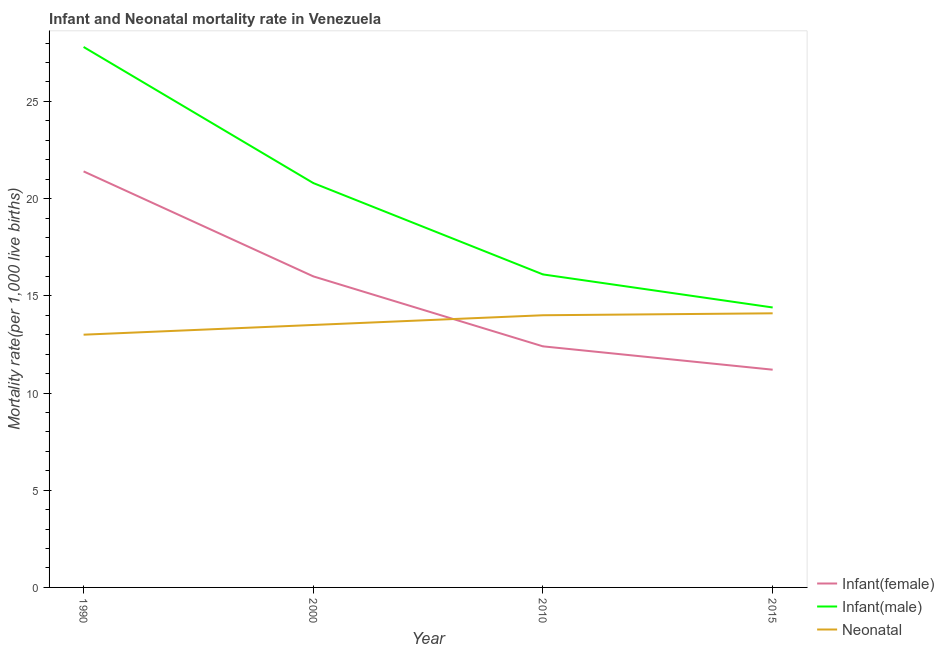How many different coloured lines are there?
Provide a short and direct response. 3. Is the number of lines equal to the number of legend labels?
Your answer should be compact. Yes. Across all years, what is the maximum infant mortality rate(female)?
Give a very brief answer. 21.4. In which year was the infant mortality rate(male) minimum?
Provide a succinct answer. 2015. What is the total infant mortality rate(female) in the graph?
Ensure brevity in your answer.  61. What is the difference between the infant mortality rate(female) in 2015 and the neonatal mortality rate in 1990?
Offer a terse response. -1.8. What is the average infant mortality rate(male) per year?
Ensure brevity in your answer.  19.78. In the year 1990, what is the difference between the infant mortality rate(female) and infant mortality rate(male)?
Offer a terse response. -6.4. In how many years, is the infant mortality rate(male) greater than 6?
Ensure brevity in your answer.  4. What is the ratio of the neonatal mortality rate in 2000 to that in 2010?
Your answer should be compact. 0.96. Is the infant mortality rate(female) in 1990 less than that in 2010?
Your answer should be compact. No. Is the difference between the neonatal mortality rate in 1990 and 2010 greater than the difference between the infant mortality rate(male) in 1990 and 2010?
Keep it short and to the point. No. What is the difference between the highest and the second highest neonatal mortality rate?
Keep it short and to the point. 0.1. What is the difference between the highest and the lowest neonatal mortality rate?
Offer a very short reply. 1.1. In how many years, is the infant mortality rate(male) greater than the average infant mortality rate(male) taken over all years?
Provide a short and direct response. 2. Is it the case that in every year, the sum of the infant mortality rate(female) and infant mortality rate(male) is greater than the neonatal mortality rate?
Offer a terse response. Yes. Is the infant mortality rate(male) strictly less than the neonatal mortality rate over the years?
Your answer should be very brief. No. How many lines are there?
Provide a short and direct response. 3. What is the difference between two consecutive major ticks on the Y-axis?
Make the answer very short. 5. Are the values on the major ticks of Y-axis written in scientific E-notation?
Provide a succinct answer. No. Does the graph contain any zero values?
Offer a very short reply. No. Does the graph contain grids?
Ensure brevity in your answer.  No. Where does the legend appear in the graph?
Keep it short and to the point. Bottom right. How many legend labels are there?
Offer a very short reply. 3. How are the legend labels stacked?
Offer a very short reply. Vertical. What is the title of the graph?
Provide a short and direct response. Infant and Neonatal mortality rate in Venezuela. Does "New Zealand" appear as one of the legend labels in the graph?
Your answer should be compact. No. What is the label or title of the Y-axis?
Provide a short and direct response. Mortality rate(per 1,0 live births). What is the Mortality rate(per 1,000 live births) in Infant(female) in 1990?
Offer a terse response. 21.4. What is the Mortality rate(per 1,000 live births) in Infant(male) in 1990?
Give a very brief answer. 27.8. What is the Mortality rate(per 1,000 live births) in Infant(male) in 2000?
Offer a terse response. 20.8. What is the Mortality rate(per 1,000 live births) of Infant(female) in 2010?
Provide a short and direct response. 12.4. What is the Mortality rate(per 1,000 live births) of Infant(female) in 2015?
Provide a short and direct response. 11.2. What is the Mortality rate(per 1,000 live births) of Infant(male) in 2015?
Your answer should be very brief. 14.4. What is the Mortality rate(per 1,000 live births) in Neonatal  in 2015?
Provide a succinct answer. 14.1. Across all years, what is the maximum Mortality rate(per 1,000 live births) in Infant(female)?
Keep it short and to the point. 21.4. Across all years, what is the maximum Mortality rate(per 1,000 live births) in Infant(male)?
Your answer should be compact. 27.8. Across all years, what is the maximum Mortality rate(per 1,000 live births) of Neonatal ?
Give a very brief answer. 14.1. Across all years, what is the minimum Mortality rate(per 1,000 live births) in Infant(male)?
Your answer should be very brief. 14.4. Across all years, what is the minimum Mortality rate(per 1,000 live births) of Neonatal ?
Your answer should be very brief. 13. What is the total Mortality rate(per 1,000 live births) of Infant(male) in the graph?
Your answer should be very brief. 79.1. What is the total Mortality rate(per 1,000 live births) in Neonatal  in the graph?
Provide a succinct answer. 54.6. What is the difference between the Mortality rate(per 1,000 live births) in Infant(male) in 1990 and that in 2000?
Keep it short and to the point. 7. What is the difference between the Mortality rate(per 1,000 live births) of Infant(female) in 1990 and that in 2010?
Make the answer very short. 9. What is the difference between the Mortality rate(per 1,000 live births) in Infant(male) in 1990 and that in 2010?
Your answer should be compact. 11.7. What is the difference between the Mortality rate(per 1,000 live births) of Infant(male) in 1990 and that in 2015?
Offer a terse response. 13.4. What is the difference between the Mortality rate(per 1,000 live births) of Neonatal  in 1990 and that in 2015?
Make the answer very short. -1.1. What is the difference between the Mortality rate(per 1,000 live births) in Infant(female) in 2000 and that in 2010?
Make the answer very short. 3.6. What is the difference between the Mortality rate(per 1,000 live births) of Infant(female) in 2000 and that in 2015?
Give a very brief answer. 4.8. What is the difference between the Mortality rate(per 1,000 live births) of Infant(female) in 2010 and that in 2015?
Your answer should be very brief. 1.2. What is the difference between the Mortality rate(per 1,000 live births) in Infant(female) in 1990 and the Mortality rate(per 1,000 live births) in Infant(male) in 2000?
Give a very brief answer. 0.6. What is the difference between the Mortality rate(per 1,000 live births) of Infant(female) in 1990 and the Mortality rate(per 1,000 live births) of Infant(male) in 2015?
Make the answer very short. 7. What is the difference between the Mortality rate(per 1,000 live births) in Infant(female) in 2000 and the Mortality rate(per 1,000 live births) in Infant(male) in 2010?
Keep it short and to the point. -0.1. What is the difference between the Mortality rate(per 1,000 live births) of Infant(male) in 2000 and the Mortality rate(per 1,000 live births) of Neonatal  in 2010?
Provide a succinct answer. 6.8. What is the difference between the Mortality rate(per 1,000 live births) of Infant(female) in 2000 and the Mortality rate(per 1,000 live births) of Infant(male) in 2015?
Your answer should be compact. 1.6. What is the difference between the Mortality rate(per 1,000 live births) in Infant(female) in 2000 and the Mortality rate(per 1,000 live births) in Neonatal  in 2015?
Ensure brevity in your answer.  1.9. What is the difference between the Mortality rate(per 1,000 live births) in Infant(male) in 2000 and the Mortality rate(per 1,000 live births) in Neonatal  in 2015?
Ensure brevity in your answer.  6.7. What is the difference between the Mortality rate(per 1,000 live births) in Infant(female) in 2010 and the Mortality rate(per 1,000 live births) in Infant(male) in 2015?
Offer a terse response. -2. What is the difference between the Mortality rate(per 1,000 live births) in Infant(male) in 2010 and the Mortality rate(per 1,000 live births) in Neonatal  in 2015?
Give a very brief answer. 2. What is the average Mortality rate(per 1,000 live births) in Infant(female) per year?
Your response must be concise. 15.25. What is the average Mortality rate(per 1,000 live births) in Infant(male) per year?
Your answer should be very brief. 19.77. What is the average Mortality rate(per 1,000 live births) of Neonatal  per year?
Provide a short and direct response. 13.65. In the year 1990, what is the difference between the Mortality rate(per 1,000 live births) in Infant(female) and Mortality rate(per 1,000 live births) in Neonatal ?
Your answer should be very brief. 8.4. In the year 2000, what is the difference between the Mortality rate(per 1,000 live births) of Infant(male) and Mortality rate(per 1,000 live births) of Neonatal ?
Keep it short and to the point. 7.3. In the year 2010, what is the difference between the Mortality rate(per 1,000 live births) in Infant(female) and Mortality rate(per 1,000 live births) in Infant(male)?
Your answer should be very brief. -3.7. In the year 2010, what is the difference between the Mortality rate(per 1,000 live births) in Infant(female) and Mortality rate(per 1,000 live births) in Neonatal ?
Make the answer very short. -1.6. In the year 2010, what is the difference between the Mortality rate(per 1,000 live births) of Infant(male) and Mortality rate(per 1,000 live births) of Neonatal ?
Offer a very short reply. 2.1. In the year 2015, what is the difference between the Mortality rate(per 1,000 live births) in Infant(female) and Mortality rate(per 1,000 live births) in Neonatal ?
Ensure brevity in your answer.  -2.9. What is the ratio of the Mortality rate(per 1,000 live births) of Infant(female) in 1990 to that in 2000?
Make the answer very short. 1.34. What is the ratio of the Mortality rate(per 1,000 live births) of Infant(male) in 1990 to that in 2000?
Offer a very short reply. 1.34. What is the ratio of the Mortality rate(per 1,000 live births) in Neonatal  in 1990 to that in 2000?
Your response must be concise. 0.96. What is the ratio of the Mortality rate(per 1,000 live births) of Infant(female) in 1990 to that in 2010?
Give a very brief answer. 1.73. What is the ratio of the Mortality rate(per 1,000 live births) in Infant(male) in 1990 to that in 2010?
Ensure brevity in your answer.  1.73. What is the ratio of the Mortality rate(per 1,000 live births) of Infant(female) in 1990 to that in 2015?
Your answer should be very brief. 1.91. What is the ratio of the Mortality rate(per 1,000 live births) of Infant(male) in 1990 to that in 2015?
Provide a succinct answer. 1.93. What is the ratio of the Mortality rate(per 1,000 live births) of Neonatal  in 1990 to that in 2015?
Offer a very short reply. 0.92. What is the ratio of the Mortality rate(per 1,000 live births) of Infant(female) in 2000 to that in 2010?
Make the answer very short. 1.29. What is the ratio of the Mortality rate(per 1,000 live births) in Infant(male) in 2000 to that in 2010?
Offer a terse response. 1.29. What is the ratio of the Mortality rate(per 1,000 live births) of Neonatal  in 2000 to that in 2010?
Your answer should be very brief. 0.96. What is the ratio of the Mortality rate(per 1,000 live births) of Infant(female) in 2000 to that in 2015?
Provide a short and direct response. 1.43. What is the ratio of the Mortality rate(per 1,000 live births) in Infant(male) in 2000 to that in 2015?
Ensure brevity in your answer.  1.44. What is the ratio of the Mortality rate(per 1,000 live births) of Neonatal  in 2000 to that in 2015?
Your answer should be very brief. 0.96. What is the ratio of the Mortality rate(per 1,000 live births) of Infant(female) in 2010 to that in 2015?
Your response must be concise. 1.11. What is the ratio of the Mortality rate(per 1,000 live births) in Infant(male) in 2010 to that in 2015?
Give a very brief answer. 1.12. What is the difference between the highest and the second highest Mortality rate(per 1,000 live births) of Infant(female)?
Make the answer very short. 5.4. What is the difference between the highest and the second highest Mortality rate(per 1,000 live births) of Infant(male)?
Provide a short and direct response. 7. What is the difference between the highest and the second highest Mortality rate(per 1,000 live births) of Neonatal ?
Provide a succinct answer. 0.1. What is the difference between the highest and the lowest Mortality rate(per 1,000 live births) of Infant(female)?
Keep it short and to the point. 10.2. What is the difference between the highest and the lowest Mortality rate(per 1,000 live births) of Infant(male)?
Your answer should be very brief. 13.4. What is the difference between the highest and the lowest Mortality rate(per 1,000 live births) in Neonatal ?
Your answer should be compact. 1.1. 